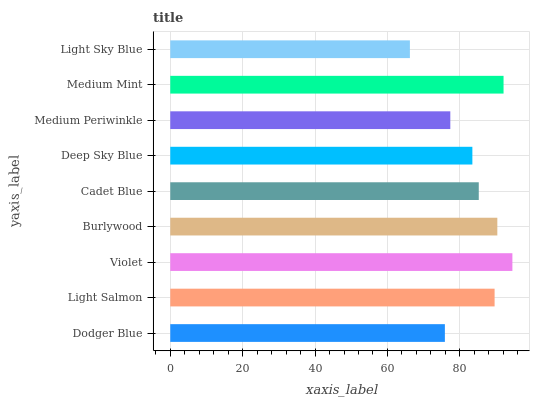Is Light Sky Blue the minimum?
Answer yes or no. Yes. Is Violet the maximum?
Answer yes or no. Yes. Is Light Salmon the minimum?
Answer yes or no. No. Is Light Salmon the maximum?
Answer yes or no. No. Is Light Salmon greater than Dodger Blue?
Answer yes or no. Yes. Is Dodger Blue less than Light Salmon?
Answer yes or no. Yes. Is Dodger Blue greater than Light Salmon?
Answer yes or no. No. Is Light Salmon less than Dodger Blue?
Answer yes or no. No. Is Cadet Blue the high median?
Answer yes or no. Yes. Is Cadet Blue the low median?
Answer yes or no. Yes. Is Medium Periwinkle the high median?
Answer yes or no. No. Is Medium Periwinkle the low median?
Answer yes or no. No. 